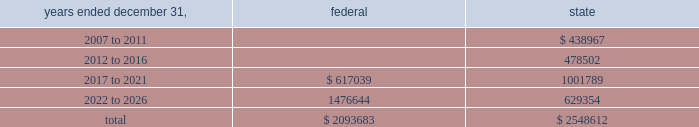American tower corporation and subsidiaries notes to consolidated financial statements 2014 ( continued ) basis step-up from corporate restructuring represents the tax effects of increasing the basis for tax purposes of certain of the company 2019s assets in conjunction with its spin-off from american radio systems corporation , its former parent company .
At december 31 , 2006 , the company had net federal and state operating loss carryforwards available to reduce future taxable income of approximately $ 2.1 billion and $ 2.5 billion , respectively .
If not utilized , the company 2019s net operating loss carryforwards expire as follows ( in thousands ) : .
Sfas no .
109 , 201caccounting for income taxes , 201d requires that companies record a valuation allowance when it is 201cmore likely than not that some portion or all of the deferred tax assets will not be realized . 201d at december 31 , 2006 , the company has provided a valuation allowance of approximately $ 308.2 million , including approximately $ 153.6 million attributable to spectrasite , primarily related to net operating loss and capital loss carryforwards assumed as of the acquisition date .
The balance of the valuation allowance primarily relates to net state deferred tax assets .
The company has not provided a valuation allowance for the remaining deferred tax assets , primarily its federal net operating loss carryforwards , as management believes the company will have sufficient time to realize these federal net operating loss carryforwards during the twenty-year tax carryforward period .
Valuation allowances may be reversed if related deferred tax assets are deemed realizable based on changes in facts and circumstances relevant to the assets 2019 recoverability .
Approximately $ 148.3 million of the spectrasite valuation allowances as of december 31 , 2006 will be recorded as a reduction to goodwill if the underlying deferred tax assets are utilized .
The company intends to recover a portion of its deferred tax asset through its federal income tax refund claims related to the carry back of certain federal net operating losses .
In june 2003 and october 2003 , the company filed federal income tax refund claims with the irs relating to the carry back of $ 380.0 million of net operating losses generated prior to 2003 , of which the company initially anticipated receiving approximately $ 90.0 million .
Based on preliminary discussions with tax authorities , the company revised its estimate of the net realizable value of the federal income tax refund claims during the year ended december 31 , 2005 , and anticipates receiving a refund of approximately $ 65.0 million , plus interest .
The company expects settlement of this matter in the first half of 2007 , however , there can be no assurances with respect to the timing of any refund .
Because of the uncertainty associated with the claim , the company has not recognized any amounts related to interest .
The recoverability of the company 2019s remaining net deferred tax asset has been assessed utilizing stable state ( no growth ) projections based on its current operations .
The projections show a significant decrease in depreciation in the later years of the carryforward period as a result of a significant portion of its assets being fully depreciated during the first fifteen years of the carryforward period .
Accordingly , the recoverability of the net deferred tax asset is not dependent on material improvements to operations , material asset sales or other non-routine transactions .
Based on its current outlook of future taxable income during the carryforward period , management believes that the net deferred tax asset will be realized .
The realization of the company 2019s deferred tax assets as of december 31 , 2006 will be dependent upon its ability to generate approximately $ 1.4 billion in taxable income from january 1 , 2007 to december 31 , 2026 .
If the company is unable to generate sufficient taxable income in the future , or carry back losses , as described above , it .
What portion of state operating loss carryforwards expire between 2017 and 2021? 
Computations: (1001789 / 2548612)
Answer: 0.39307. 